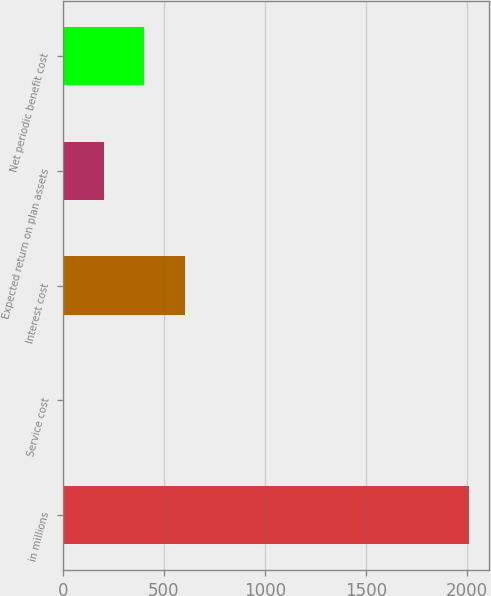<chart> <loc_0><loc_0><loc_500><loc_500><bar_chart><fcel>in millions<fcel>Service cost<fcel>Interest cost<fcel>Expected return on plan assets<fcel>Net periodic benefit cost<nl><fcel>2011<fcel>0.5<fcel>603.65<fcel>201.55<fcel>402.6<nl></chart> 